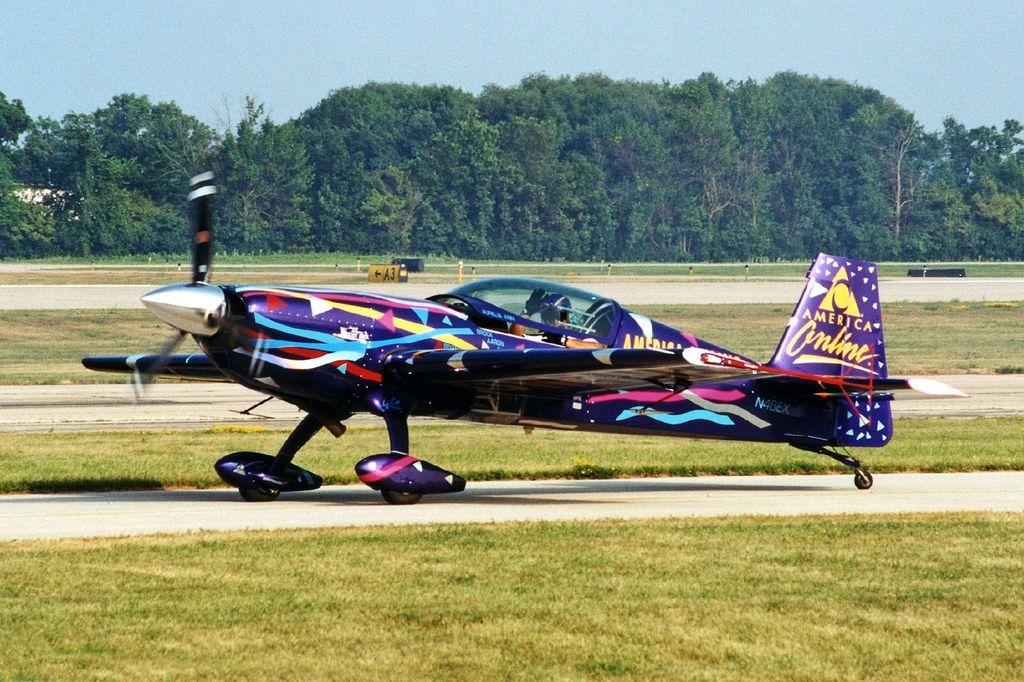Provide a one-sentence caption for the provided image. A wildly painted airplane with the words America Online on the tail sits on the runway. 